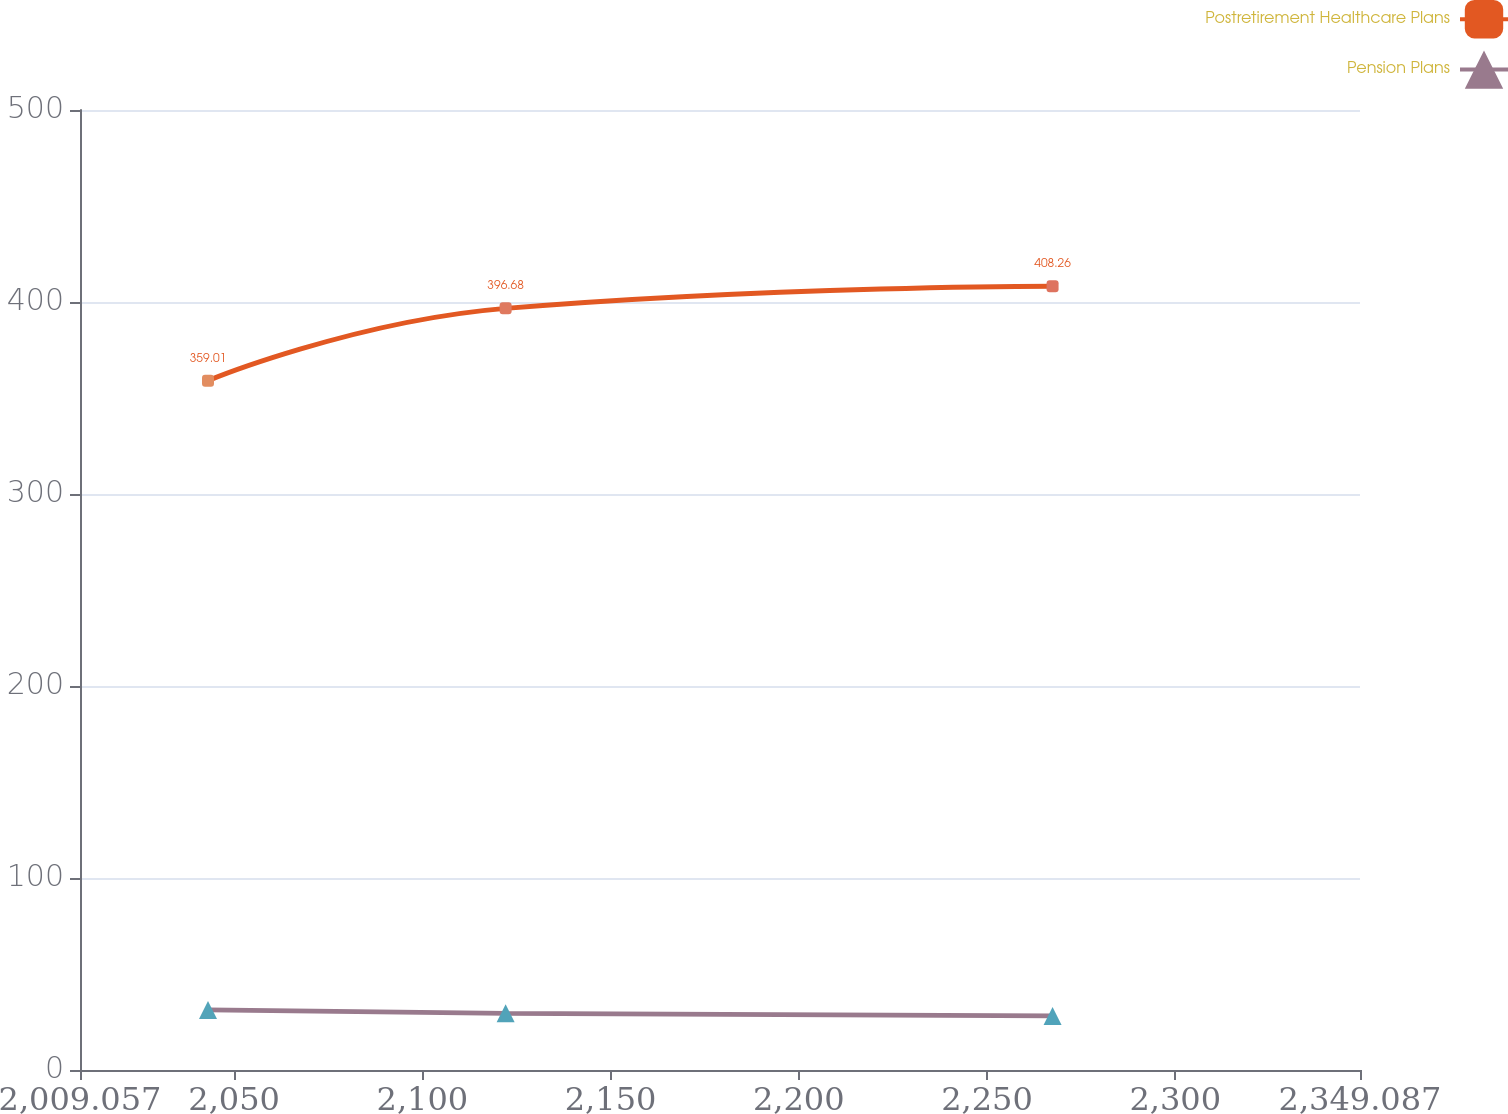Convert chart to OTSL. <chart><loc_0><loc_0><loc_500><loc_500><line_chart><ecel><fcel>Postretirement Healthcare Plans<fcel>Pension Plans<nl><fcel>2043.06<fcel>359.01<fcel>31.3<nl><fcel>2122.12<fcel>396.68<fcel>29.51<nl><fcel>2267.42<fcel>408.26<fcel>28.17<nl><fcel>2350.67<fcel>465.1<fcel>32.63<nl><fcel>2383.09<fcel>476.68<fcel>41.52<nl></chart> 